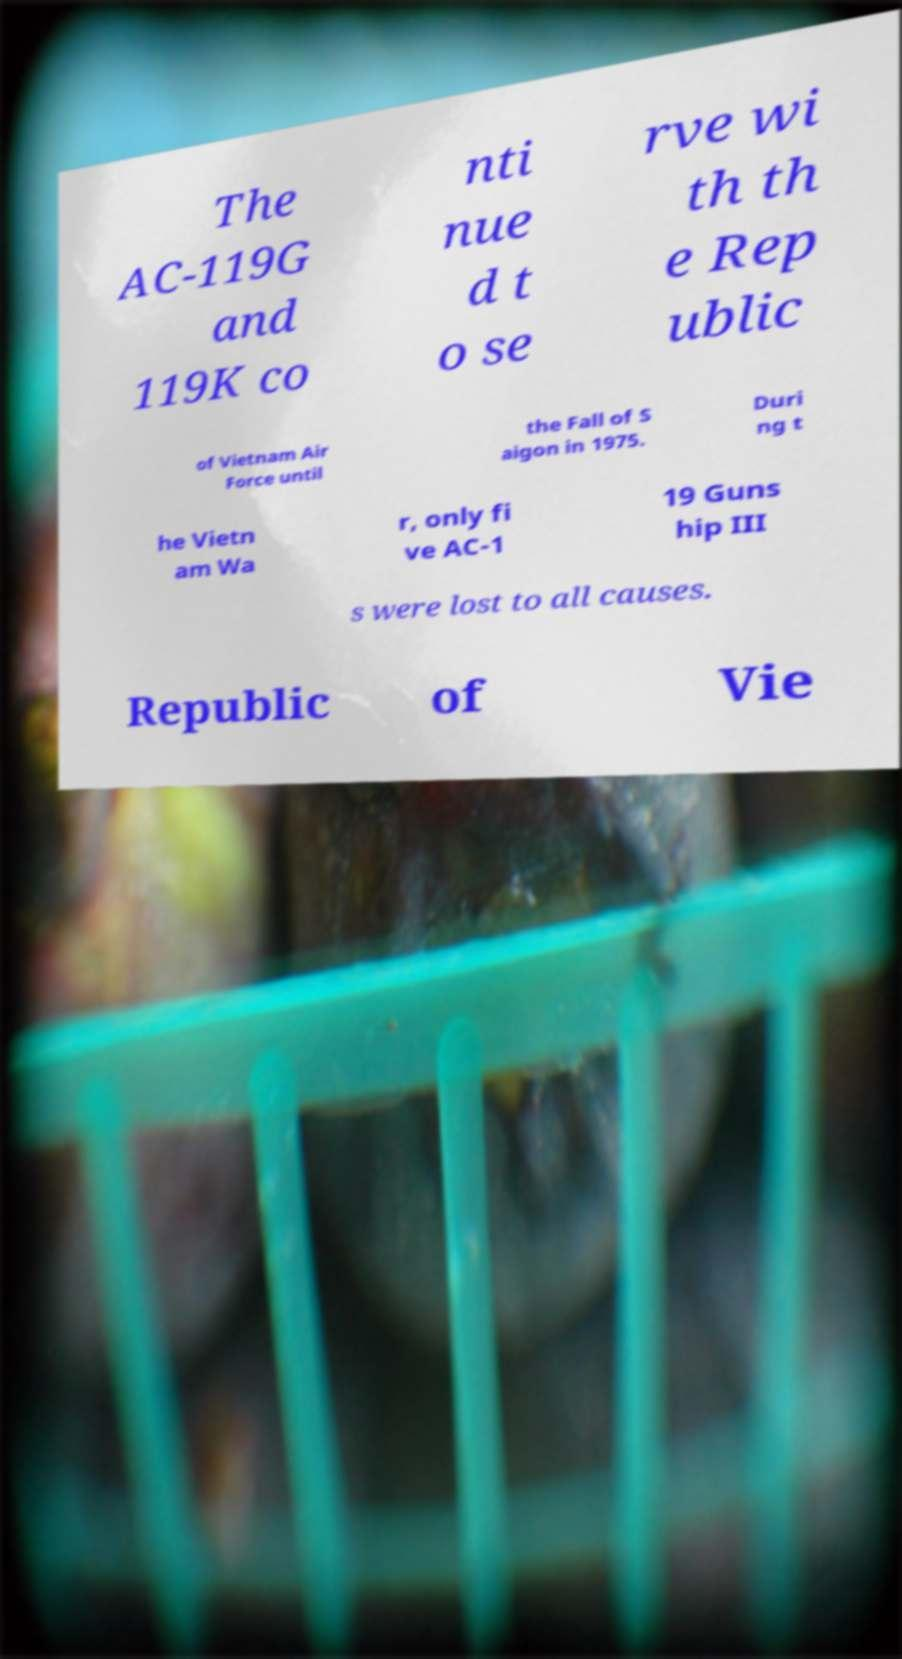For documentation purposes, I need the text within this image transcribed. Could you provide that? The AC-119G and 119K co nti nue d t o se rve wi th th e Rep ublic of Vietnam Air Force until the Fall of S aigon in 1975. Duri ng t he Vietn am Wa r, only fi ve AC-1 19 Guns hip III s were lost to all causes. Republic of Vie 